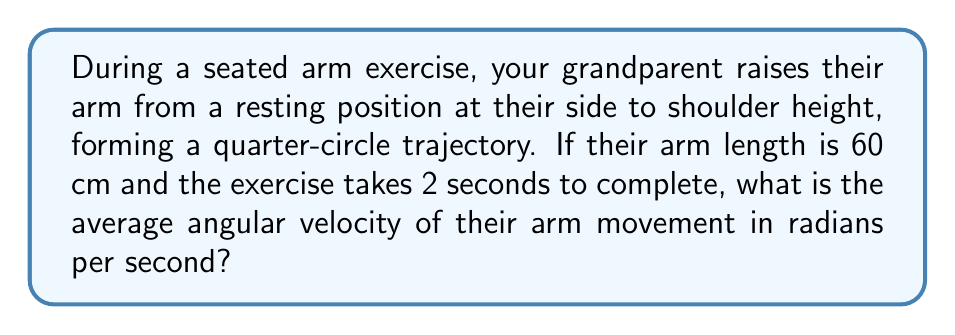Teach me how to tackle this problem. Let's approach this step-by-step:

1) First, we need to understand what a quarter-circle represents in terms of angle:
   A full circle is $2\pi$ radians, so a quarter-circle is $\frac{\pi}{2}$ radians.

2) The angular displacement is therefore $\frac{\pi}{2}$ radians.

3) The time taken for this movement is given as 2 seconds.

4) The formula for average angular velocity $(\omega)$ is:

   $$\omega = \frac{\text{angular displacement}}{\text{time}}$$

5) Substituting our values:

   $$\omega = \frac{\frac{\pi}{2}}{2}$$

6) Simplifying:

   $$\omega = \frac{\pi}{4}$$

Note: The arm length (60 cm) is not needed for this calculation, as angular velocity is independent of the radius of rotation.
Answer: $\frac{\pi}{4}$ rad/s 